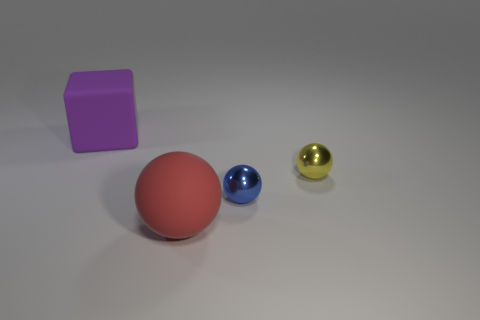Is there a large sphere made of the same material as the tiny blue object?
Offer a terse response. No. Does the large object that is behind the red matte ball have the same material as the tiny thing on the right side of the blue metallic sphere?
Make the answer very short. No. What number of blue rubber cubes are there?
Offer a terse response. 0. There is a thing that is left of the big red matte object; what is its shape?
Your response must be concise. Cube. How many other things are there of the same size as the yellow ball?
Your answer should be very brief. 1. Does the big matte object in front of the block have the same shape as the metal thing on the right side of the blue ball?
Your response must be concise. Yes. There is a big block; how many tiny yellow objects are on the left side of it?
Give a very brief answer. 0. What color is the large object to the left of the big rubber ball?
Provide a short and direct response. Purple. What color is the rubber thing that is the same shape as the small yellow metallic thing?
Your response must be concise. Red. Is there any other thing of the same color as the big matte block?
Provide a short and direct response. No. 